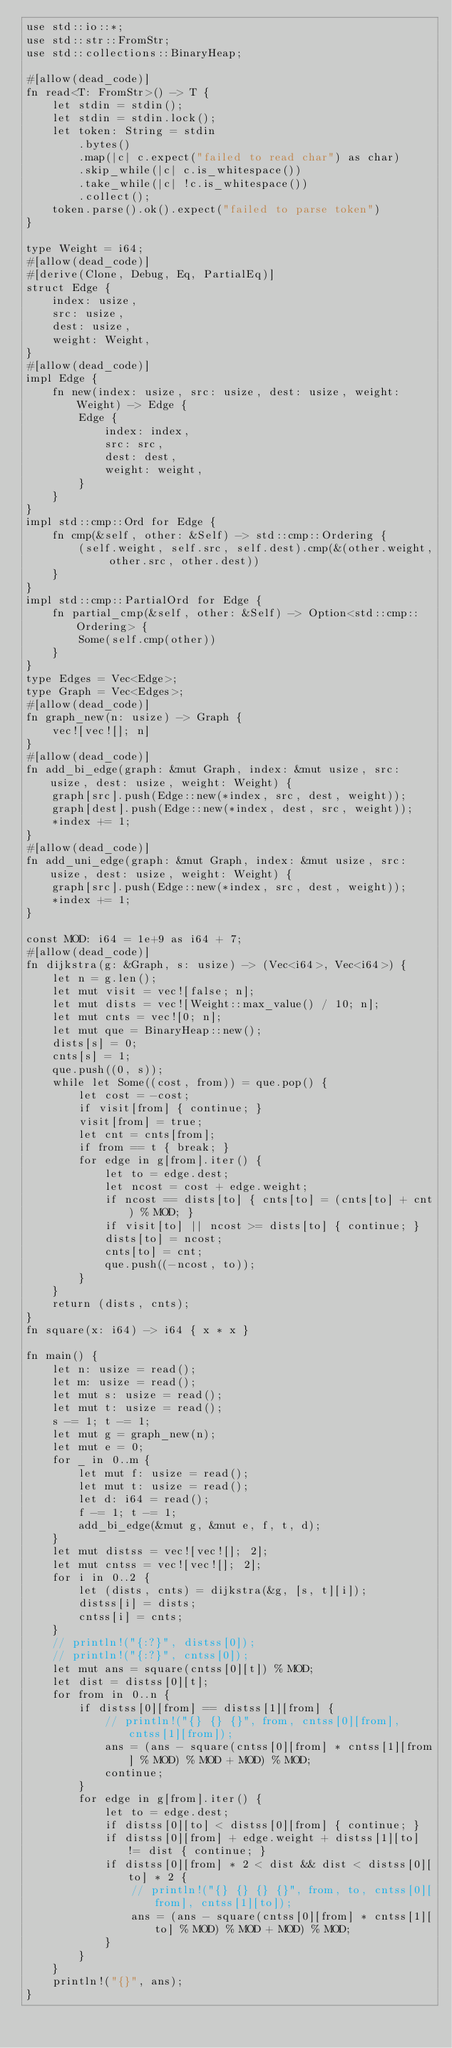<code> <loc_0><loc_0><loc_500><loc_500><_Rust_>use std::io::*;
use std::str::FromStr;
use std::collections::BinaryHeap;

#[allow(dead_code)]
fn read<T: FromStr>() -> T {
    let stdin = stdin();
    let stdin = stdin.lock();
    let token: String = stdin
        .bytes()
        .map(|c| c.expect("failed to read char") as char)
        .skip_while(|c| c.is_whitespace())
        .take_while(|c| !c.is_whitespace())
        .collect();
    token.parse().ok().expect("failed to parse token")
}

type Weight = i64;
#[allow(dead_code)]
#[derive(Clone, Debug, Eq, PartialEq)]
struct Edge {
    index: usize,
    src: usize,
    dest: usize,
    weight: Weight,
}
#[allow(dead_code)]
impl Edge {
    fn new(index: usize, src: usize, dest: usize, weight: Weight) -> Edge {
        Edge {
            index: index,
            src: src,
            dest: dest,
            weight: weight,
        }
    }
}
impl std::cmp::Ord for Edge {
    fn cmp(&self, other: &Self) -> std::cmp::Ordering {
        (self.weight, self.src, self.dest).cmp(&(other.weight, other.src, other.dest))
    }
}
impl std::cmp::PartialOrd for Edge {
    fn partial_cmp(&self, other: &Self) -> Option<std::cmp::Ordering> {
        Some(self.cmp(other))
    }
}
type Edges = Vec<Edge>;
type Graph = Vec<Edges>;
#[allow(dead_code)]
fn graph_new(n: usize) -> Graph {
    vec![vec![]; n]
}
#[allow(dead_code)]
fn add_bi_edge(graph: &mut Graph, index: &mut usize, src: usize, dest: usize, weight: Weight) {
    graph[src].push(Edge::new(*index, src, dest, weight));
    graph[dest].push(Edge::new(*index, dest, src, weight));
    *index += 1;
}
#[allow(dead_code)]
fn add_uni_edge(graph: &mut Graph, index: &mut usize, src: usize, dest: usize, weight: Weight) {
    graph[src].push(Edge::new(*index, src, dest, weight));
    *index += 1;
}

const MOD: i64 = 1e+9 as i64 + 7;
#[allow(dead_code)]
fn dijkstra(g: &Graph, s: usize) -> (Vec<i64>, Vec<i64>) {
    let n = g.len();
    let mut visit = vec![false; n];
    let mut dists = vec![Weight::max_value() / 10; n];
    let mut cnts = vec![0; n];
    let mut que = BinaryHeap::new();
    dists[s] = 0;
    cnts[s] = 1;
    que.push((0, s));
    while let Some((cost, from)) = que.pop() {
        let cost = -cost;
        if visit[from] { continue; }
        visit[from] = true;
        let cnt = cnts[from];
        if from == t { break; }
        for edge in g[from].iter() {
            let to = edge.dest;
            let ncost = cost + edge.weight;
            if ncost == dists[to] { cnts[to] = (cnts[to] + cnt) % MOD; }
            if visit[to] || ncost >= dists[to] { continue; }
            dists[to] = ncost;
            cnts[to] = cnt;
            que.push((-ncost, to));
        }
    }
    return (dists, cnts);
}
fn square(x: i64) -> i64 { x * x }

fn main() {
    let n: usize = read();
    let m: usize = read();
    let mut s: usize = read();
    let mut t: usize = read();
    s -= 1; t -= 1;
    let mut g = graph_new(n);
    let mut e = 0;
    for _ in 0..m {
        let mut f: usize = read();
        let mut t: usize = read();
        let d: i64 = read();
        f -= 1; t -= 1;
        add_bi_edge(&mut g, &mut e, f, t, d);
    }
    let mut distss = vec![vec![]; 2];
    let mut cntss = vec![vec![]; 2];
    for i in 0..2 {
        let (dists, cnts) = dijkstra(&g, [s, t][i]);
        distss[i] = dists;
        cntss[i] = cnts;
    }
    // println!("{:?}", distss[0]);
    // println!("{:?}", cntss[0]);
    let mut ans = square(cntss[0][t]) % MOD;
    let dist = distss[0][t];
    for from in 0..n {
        if distss[0][from] == distss[1][from] {
            // println!("{} {} {}", from, cntss[0][from], cntss[1][from]);
            ans = (ans - square(cntss[0][from] * cntss[1][from] % MOD) % MOD + MOD) % MOD;
            continue;
        }
        for edge in g[from].iter() {
            let to = edge.dest;
            if distss[0][to] < distss[0][from] { continue; }
            if distss[0][from] + edge.weight + distss[1][to] != dist { continue; }
            if distss[0][from] * 2 < dist && dist < distss[0][to] * 2 {
                // println!("{} {} {} {}", from, to, cntss[0][from], cntss[1][to]);
                ans = (ans - square(cntss[0][from] * cntss[1][to] % MOD) % MOD + MOD) % MOD;
            }
        }
    }
    println!("{}", ans);
}</code> 